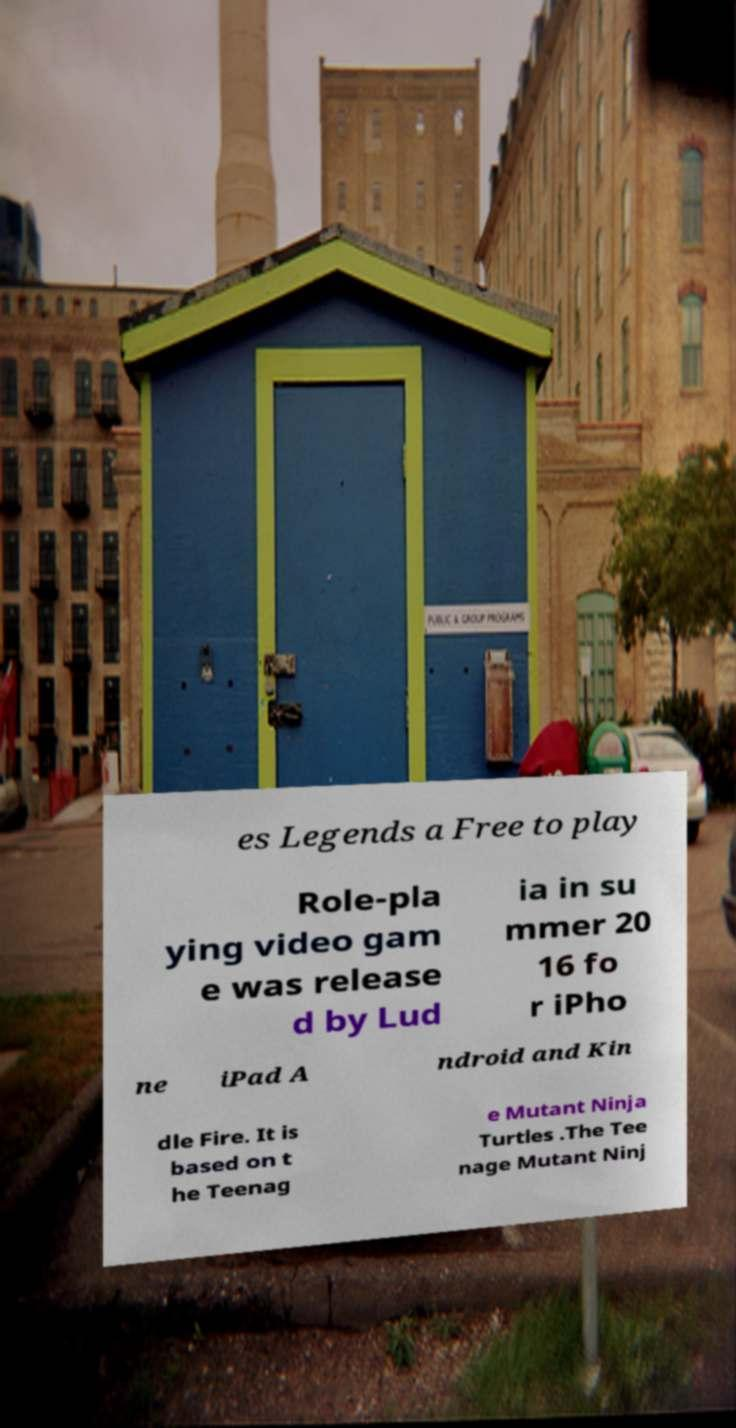I need the written content from this picture converted into text. Can you do that? es Legends a Free to play Role-pla ying video gam e was release d by Lud ia in su mmer 20 16 fo r iPho ne iPad A ndroid and Kin dle Fire. It is based on t he Teenag e Mutant Ninja Turtles .The Tee nage Mutant Ninj 